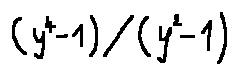Convert formula to latex. <formula><loc_0><loc_0><loc_500><loc_500>( y ^ { 4 } - 1 ) / ( y ^ { 2 } - 1 )</formula> 